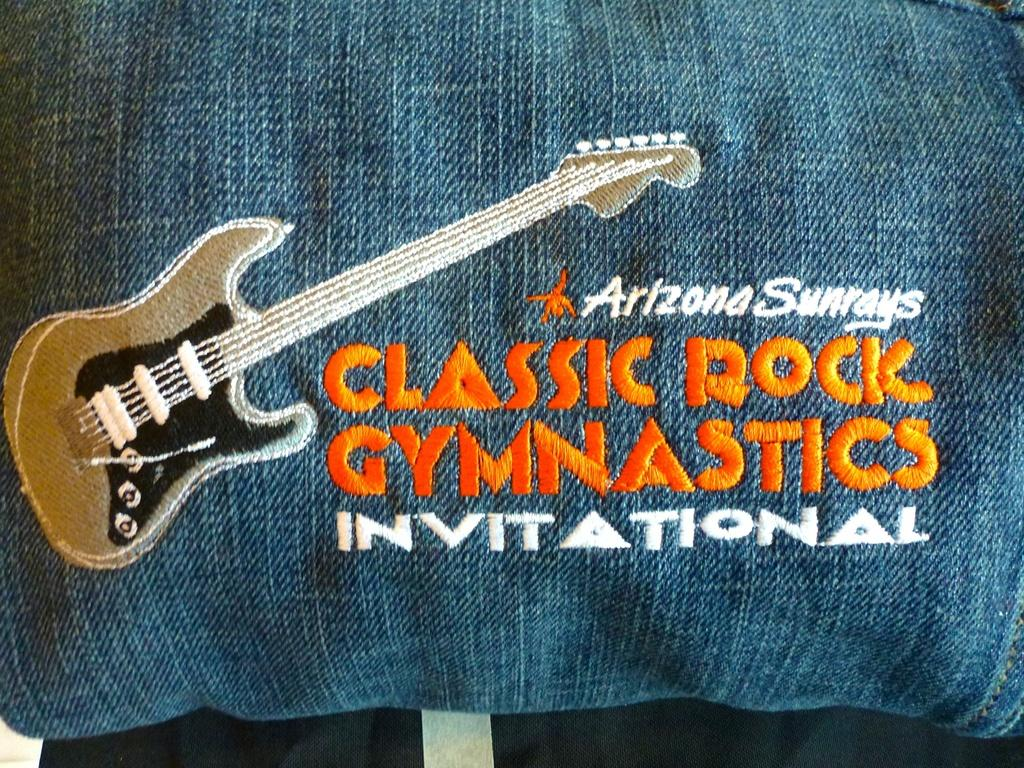What is the main object in the image? There is a cloth in the image. What is depicted on the cloth? There is an image of a guitar on the cloth. Are there any words or letters on the cloth? Yes, there is text written on the cloth. What can be seen at the bottom of the image? There is a black object at the bottom of the image. Can you see the moon in the image? No, the moon is not present in the image. Are there any dinosaurs depicted on the cloth? No, there are no dinosaurs depicted on the cloth; it features an image of a guitar. 